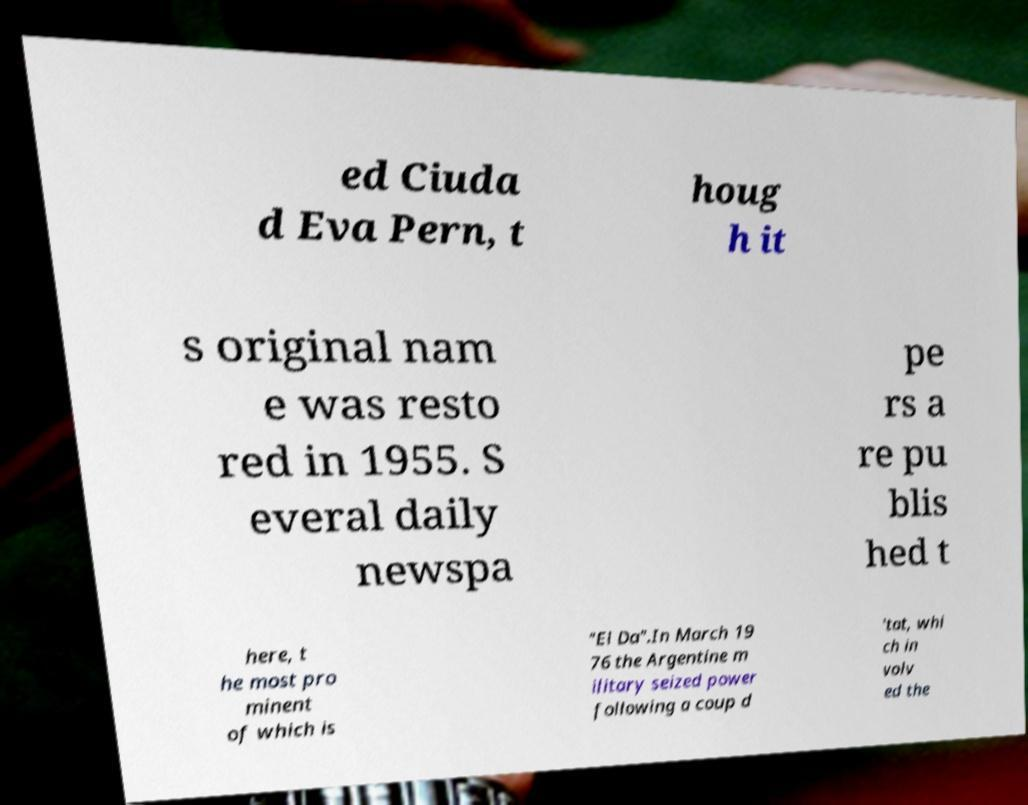Could you extract and type out the text from this image? ed Ciuda d Eva Pern, t houg h it s original nam e was resto red in 1955. S everal daily newspa pe rs a re pu blis hed t here, t he most pro minent of which is "El Da".In March 19 76 the Argentine m ilitary seized power following a coup d 'tat, whi ch in volv ed the 